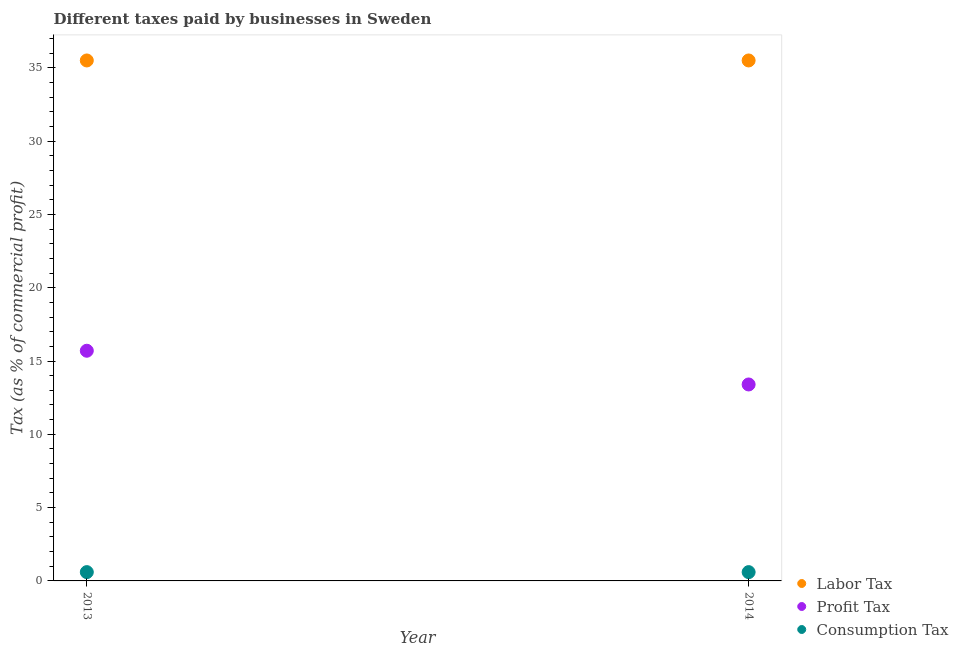How many different coloured dotlines are there?
Your answer should be compact. 3. Is the number of dotlines equal to the number of legend labels?
Provide a short and direct response. Yes. What is the percentage of labor tax in 2013?
Make the answer very short. 35.5. In which year was the percentage of labor tax maximum?
Your answer should be very brief. 2013. What is the total percentage of labor tax in the graph?
Your answer should be compact. 71. What is the difference between the percentage of profit tax in 2013 and that in 2014?
Keep it short and to the point. 2.3. What is the difference between the percentage of profit tax in 2014 and the percentage of consumption tax in 2013?
Ensure brevity in your answer.  12.8. What is the average percentage of profit tax per year?
Keep it short and to the point. 14.55. What is the ratio of the percentage of profit tax in 2013 to that in 2014?
Make the answer very short. 1.17. Is the percentage of consumption tax in 2013 less than that in 2014?
Keep it short and to the point. No. In how many years, is the percentage of labor tax greater than the average percentage of labor tax taken over all years?
Keep it short and to the point. 0. Is it the case that in every year, the sum of the percentage of labor tax and percentage of profit tax is greater than the percentage of consumption tax?
Provide a short and direct response. Yes. Does the percentage of profit tax monotonically increase over the years?
Provide a succinct answer. No. Is the percentage of profit tax strictly greater than the percentage of labor tax over the years?
Make the answer very short. No. Is the percentage of labor tax strictly less than the percentage of profit tax over the years?
Provide a short and direct response. No. Are the values on the major ticks of Y-axis written in scientific E-notation?
Offer a very short reply. No. Does the graph contain grids?
Offer a terse response. No. How many legend labels are there?
Your answer should be very brief. 3. How are the legend labels stacked?
Give a very brief answer. Vertical. What is the title of the graph?
Offer a terse response. Different taxes paid by businesses in Sweden. Does "Labor Tax" appear as one of the legend labels in the graph?
Ensure brevity in your answer.  Yes. What is the label or title of the X-axis?
Give a very brief answer. Year. What is the label or title of the Y-axis?
Your answer should be compact. Tax (as % of commercial profit). What is the Tax (as % of commercial profit) in Labor Tax in 2013?
Keep it short and to the point. 35.5. What is the Tax (as % of commercial profit) in Profit Tax in 2013?
Ensure brevity in your answer.  15.7. What is the Tax (as % of commercial profit) in Consumption Tax in 2013?
Keep it short and to the point. 0.6. What is the Tax (as % of commercial profit) of Labor Tax in 2014?
Offer a very short reply. 35.5. What is the Tax (as % of commercial profit) of Profit Tax in 2014?
Provide a short and direct response. 13.4. What is the Tax (as % of commercial profit) of Consumption Tax in 2014?
Offer a very short reply. 0.6. Across all years, what is the maximum Tax (as % of commercial profit) of Labor Tax?
Ensure brevity in your answer.  35.5. Across all years, what is the maximum Tax (as % of commercial profit) of Consumption Tax?
Your answer should be very brief. 0.6. Across all years, what is the minimum Tax (as % of commercial profit) of Labor Tax?
Give a very brief answer. 35.5. What is the total Tax (as % of commercial profit) of Labor Tax in the graph?
Give a very brief answer. 71. What is the total Tax (as % of commercial profit) of Profit Tax in the graph?
Keep it short and to the point. 29.1. What is the difference between the Tax (as % of commercial profit) of Consumption Tax in 2013 and that in 2014?
Your response must be concise. 0. What is the difference between the Tax (as % of commercial profit) of Labor Tax in 2013 and the Tax (as % of commercial profit) of Profit Tax in 2014?
Offer a very short reply. 22.1. What is the difference between the Tax (as % of commercial profit) in Labor Tax in 2013 and the Tax (as % of commercial profit) in Consumption Tax in 2014?
Ensure brevity in your answer.  34.9. What is the difference between the Tax (as % of commercial profit) of Profit Tax in 2013 and the Tax (as % of commercial profit) of Consumption Tax in 2014?
Your response must be concise. 15.1. What is the average Tax (as % of commercial profit) of Labor Tax per year?
Your response must be concise. 35.5. What is the average Tax (as % of commercial profit) of Profit Tax per year?
Offer a very short reply. 14.55. What is the average Tax (as % of commercial profit) in Consumption Tax per year?
Ensure brevity in your answer.  0.6. In the year 2013, what is the difference between the Tax (as % of commercial profit) in Labor Tax and Tax (as % of commercial profit) in Profit Tax?
Offer a terse response. 19.8. In the year 2013, what is the difference between the Tax (as % of commercial profit) of Labor Tax and Tax (as % of commercial profit) of Consumption Tax?
Your answer should be compact. 34.9. In the year 2014, what is the difference between the Tax (as % of commercial profit) in Labor Tax and Tax (as % of commercial profit) in Profit Tax?
Offer a very short reply. 22.1. In the year 2014, what is the difference between the Tax (as % of commercial profit) of Labor Tax and Tax (as % of commercial profit) of Consumption Tax?
Ensure brevity in your answer.  34.9. In the year 2014, what is the difference between the Tax (as % of commercial profit) of Profit Tax and Tax (as % of commercial profit) of Consumption Tax?
Keep it short and to the point. 12.8. What is the ratio of the Tax (as % of commercial profit) in Labor Tax in 2013 to that in 2014?
Provide a succinct answer. 1. What is the ratio of the Tax (as % of commercial profit) in Profit Tax in 2013 to that in 2014?
Provide a short and direct response. 1.17. What is the difference between the highest and the second highest Tax (as % of commercial profit) in Profit Tax?
Offer a very short reply. 2.3. What is the difference between the highest and the lowest Tax (as % of commercial profit) of Labor Tax?
Offer a terse response. 0. What is the difference between the highest and the lowest Tax (as % of commercial profit) of Consumption Tax?
Make the answer very short. 0. 